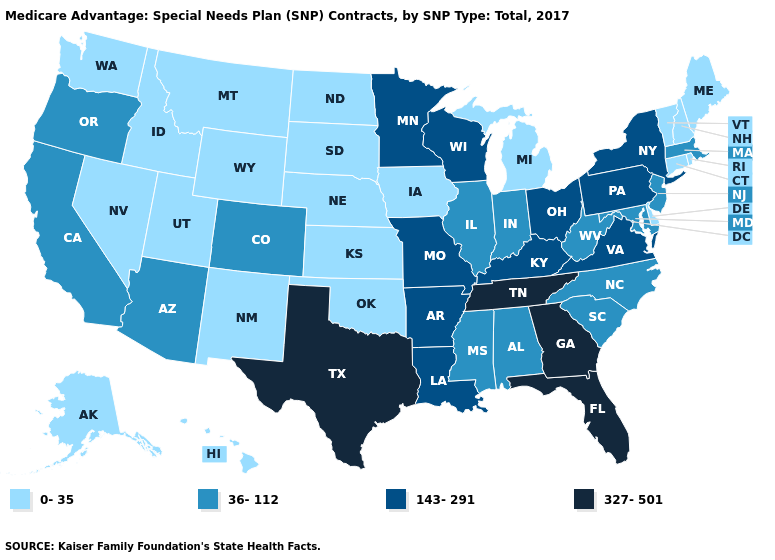What is the value of Delaware?
Be succinct. 0-35. Which states hav the highest value in the Northeast?
Concise answer only. New York, Pennsylvania. What is the value of Wyoming?
Concise answer only. 0-35. What is the value of Ohio?
Short answer required. 143-291. Name the states that have a value in the range 143-291?
Keep it brief. Arkansas, Kentucky, Louisiana, Minnesota, Missouri, New York, Ohio, Pennsylvania, Virginia, Wisconsin. What is the lowest value in the Northeast?
Write a very short answer. 0-35. Name the states that have a value in the range 36-112?
Write a very short answer. Alabama, Arizona, California, Colorado, Illinois, Indiana, Massachusetts, Maryland, Mississippi, North Carolina, New Jersey, Oregon, South Carolina, West Virginia. Name the states that have a value in the range 36-112?
Answer briefly. Alabama, Arizona, California, Colorado, Illinois, Indiana, Massachusetts, Maryland, Mississippi, North Carolina, New Jersey, Oregon, South Carolina, West Virginia. Among the states that border Louisiana , which have the highest value?
Give a very brief answer. Texas. Name the states that have a value in the range 36-112?
Keep it brief. Alabama, Arizona, California, Colorado, Illinois, Indiana, Massachusetts, Maryland, Mississippi, North Carolina, New Jersey, Oregon, South Carolina, West Virginia. Name the states that have a value in the range 36-112?
Concise answer only. Alabama, Arizona, California, Colorado, Illinois, Indiana, Massachusetts, Maryland, Mississippi, North Carolina, New Jersey, Oregon, South Carolina, West Virginia. What is the value of Kentucky?
Quick response, please. 143-291. Does the map have missing data?
Give a very brief answer. No. What is the highest value in the USA?
Keep it brief. 327-501. Among the states that border Connecticut , does Rhode Island have the lowest value?
Be succinct. Yes. 